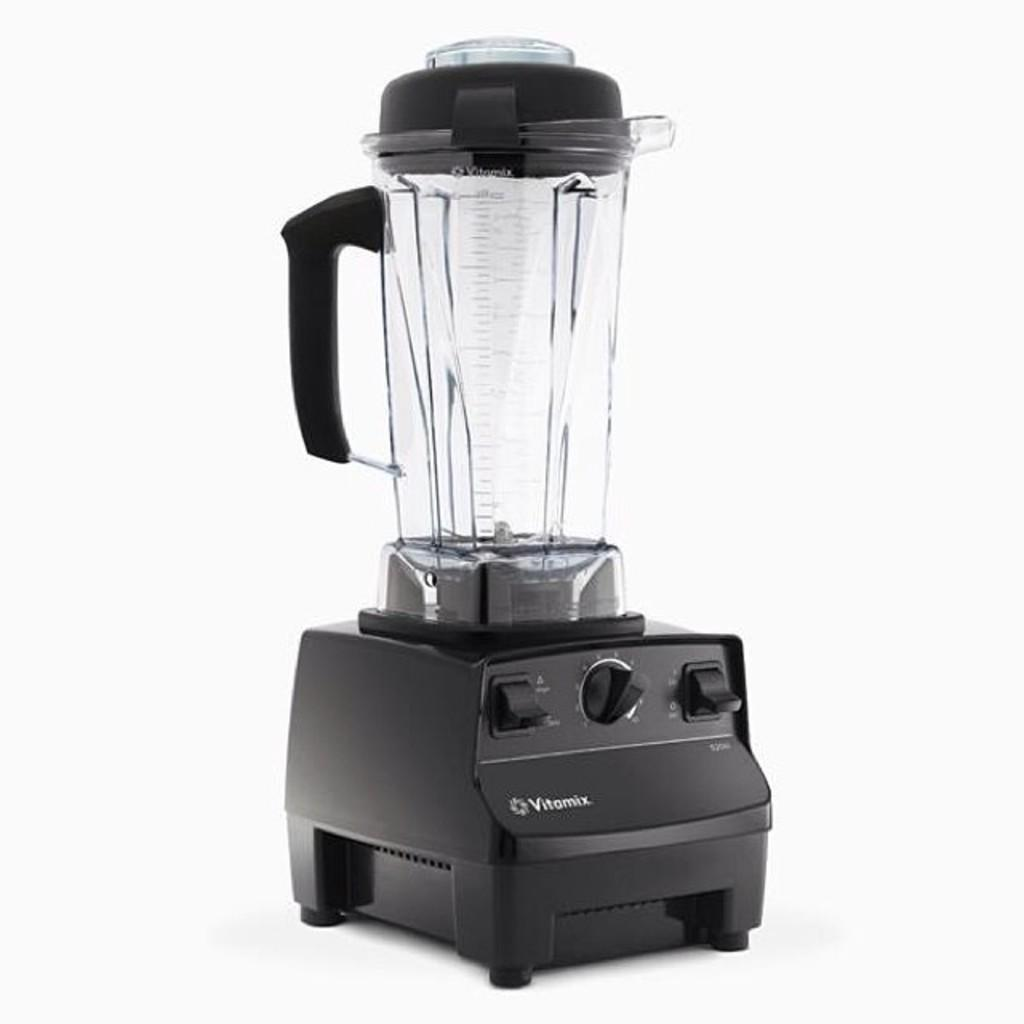<image>
Summarize the visual content of the image. The Vitamix can make for an excellent blender. 